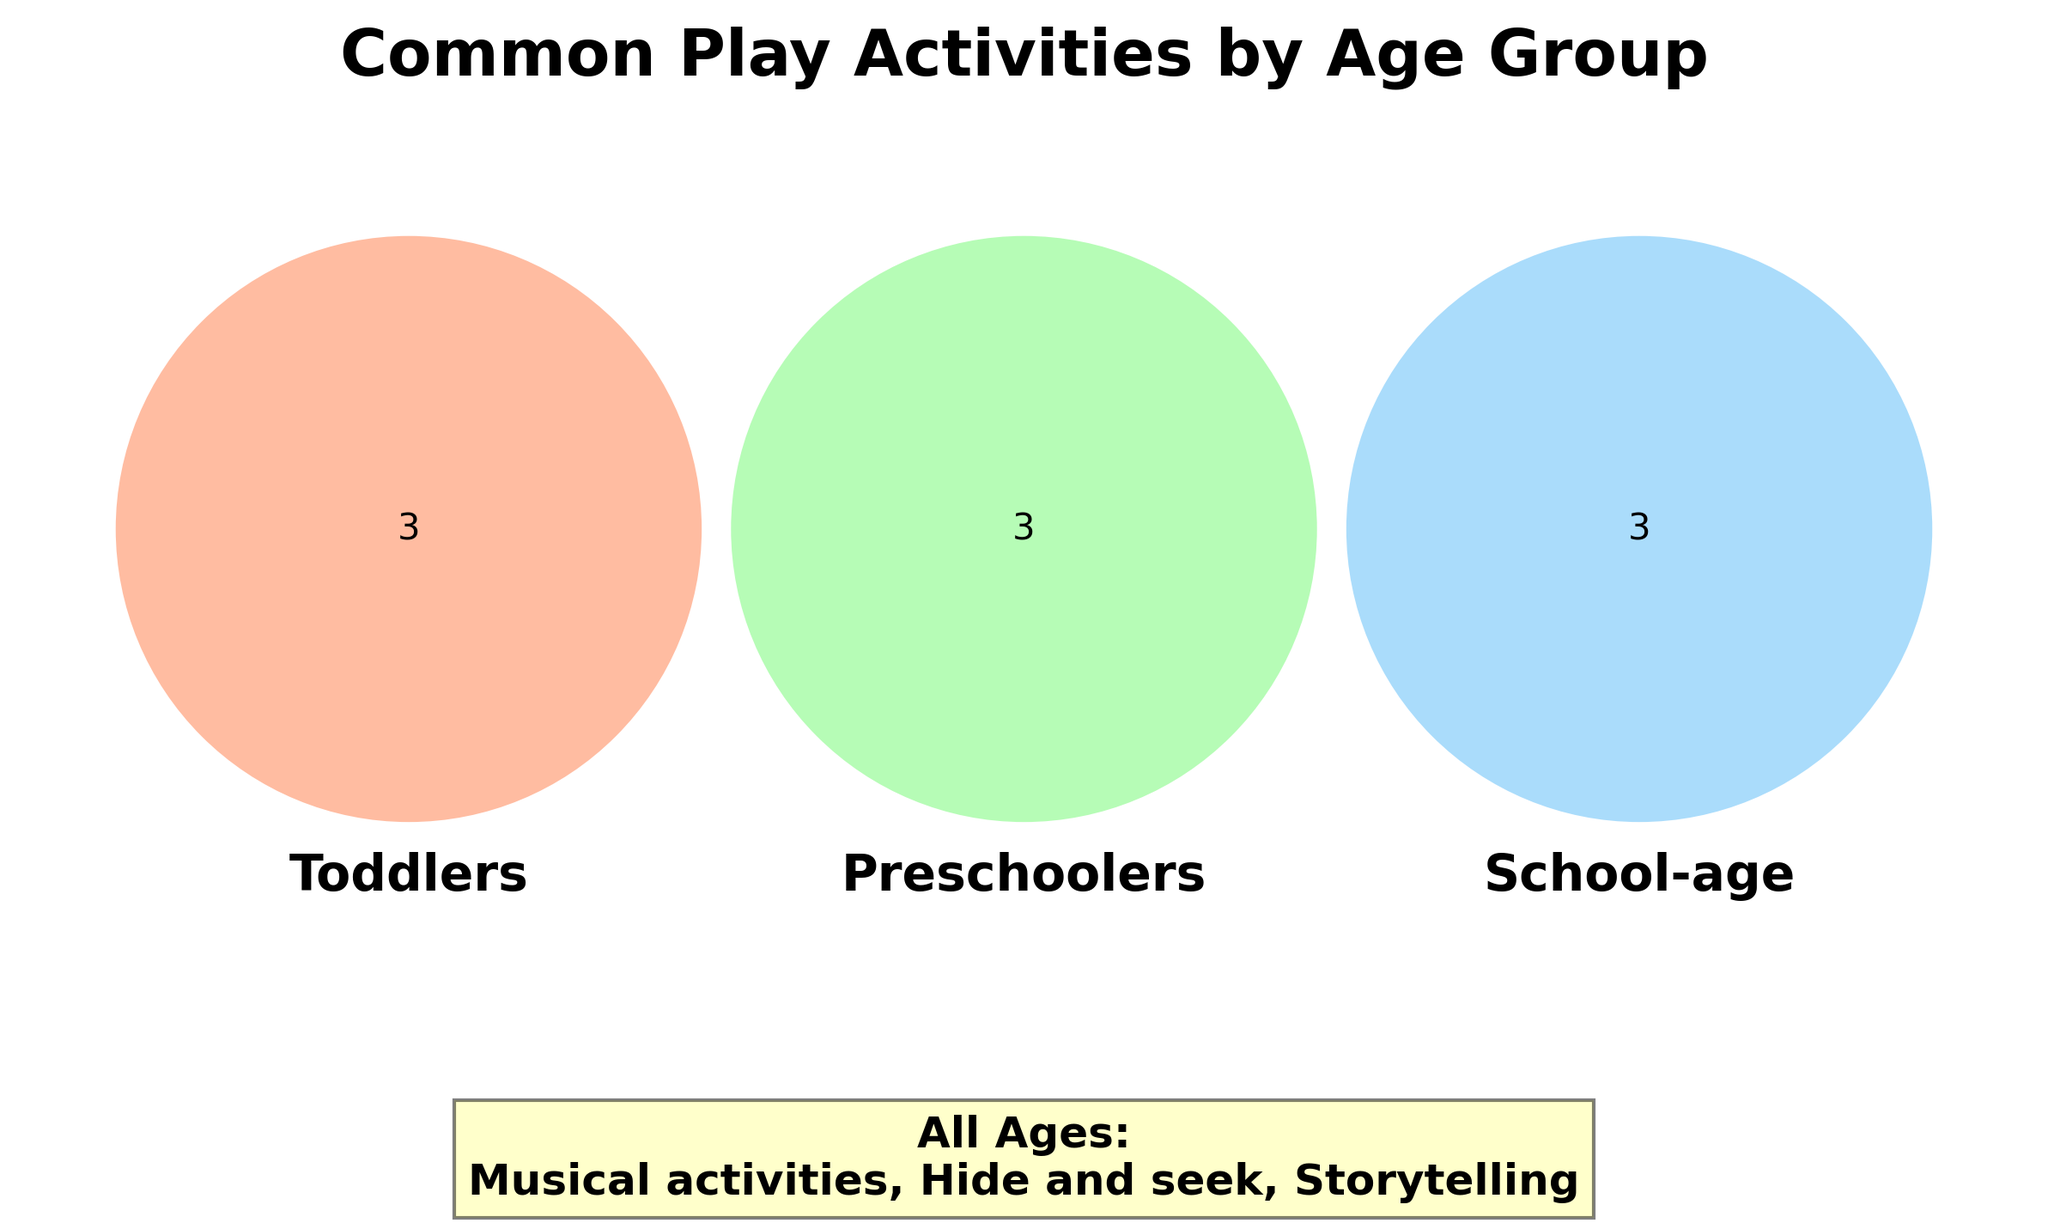What play activities are common for toddlers? The diagram shows the specific section for toddlers, indicating the activities categorized for them. These activities are "Sandbox play," "Building blocks," and "Simple puzzles."
Answer: Sandbox play, Building blocks, Simple puzzles Which play activities are common for all age groups? The figure includes a separate text annotation below the Venn diagram specifically listing activities common across all age groups as "Hide and seek," "Storytelling," and "Musical activities."
Answer: Hide and seek, Storytelling, Musical activities What are the shared play activities between preschoolers and school-age children? The section where the circles representing preschoolers and school-age children overlap indicates the shared play activities. However, in this case, there is no overlap between these two groups in the figure.
Answer: None Which age group has dress-up games as one of its activities? Looking at the sections labeled for each age group, "Dress-up games" is listed under the category for preschoolers (3-5 years).
Answer: Preschoolers How many unique play activities are shown in the Venn diagram? To determine this, you would count all the unique activities listed in the separate sections for each age group as well as the activities listed for "All Ages." The total is the sum of unique activities in each category without counting any activity twice. There are 3 (toddlers) + 3 (preschoolers) + 3 (school-age) + 3 (all ages) = 12 unique activities.
Answer: 12 Which group exclusively participates in activities like “Board games” and “Video games”? By examining the specific sections of the Venn diagram, we identify that both "Board games" and "Video games" are listed under the school-age (6-12) category without overlapping with any other group's activities.
Answer: School-age Is there any play activity common to all three specific age groups (i.e., toddlers, preschoolers, and school-age)? We need to look for an overlapping section among all three age groups. The diagram does not show an overlapping section for all three specific age groups combined.
Answer: No 